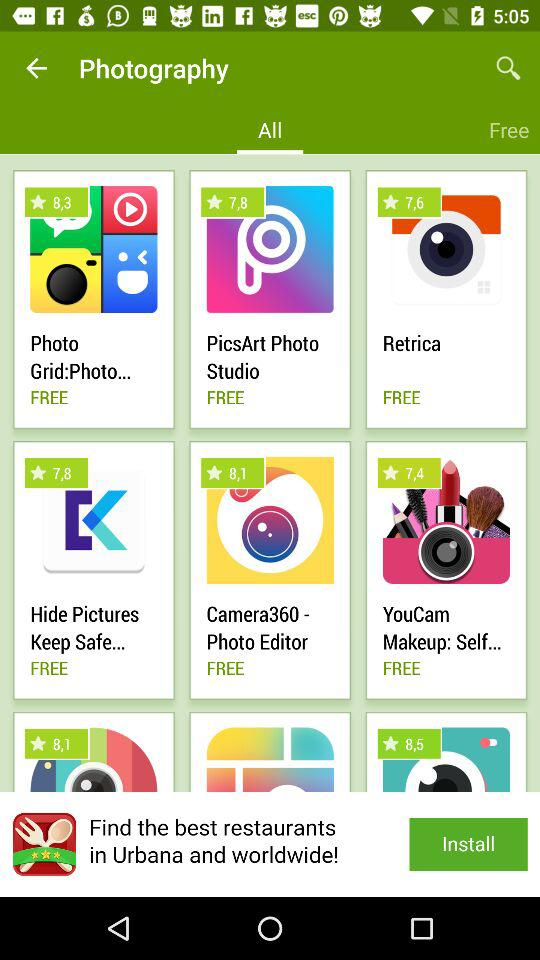What is the rating for the "Photo Grid:Photo..." app? The rating is 8.3. 